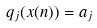<formula> <loc_0><loc_0><loc_500><loc_500>q _ { j } ( x ( n ) ) = a _ { j }</formula> 